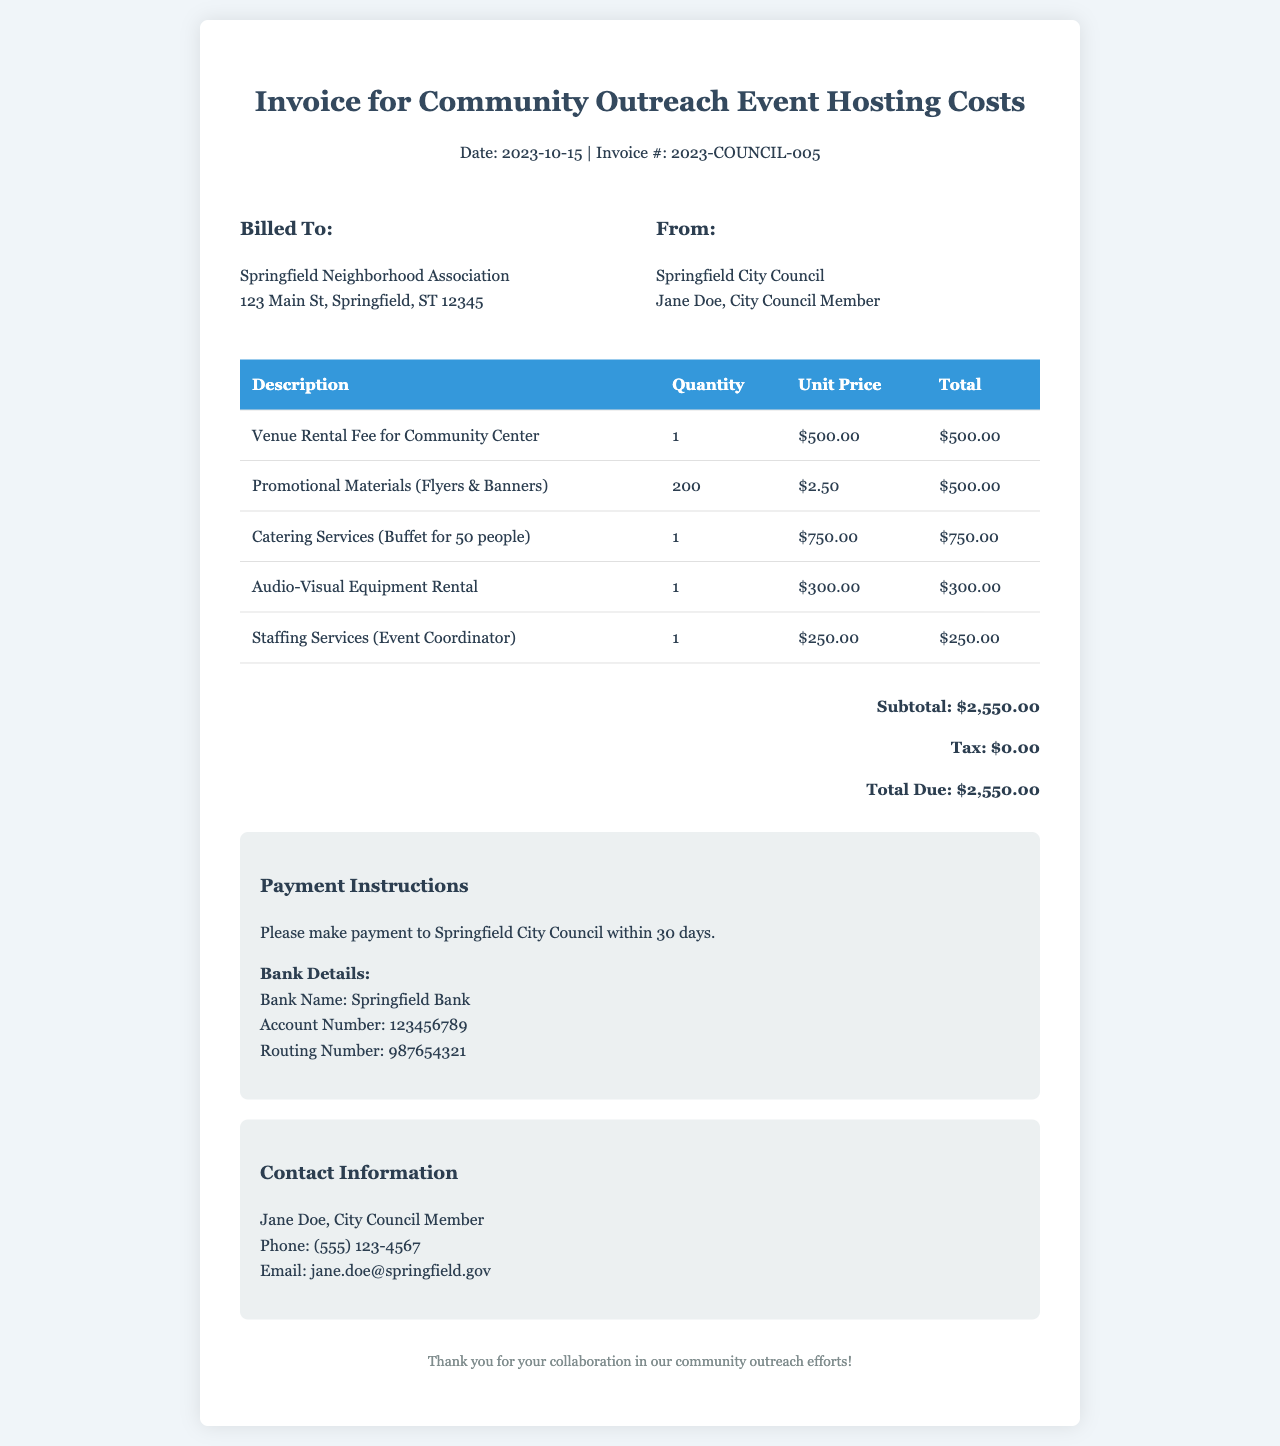What is the date of the invoice? The date is specified in the header of the invoice.
Answer: 2023-10-15 Who is billed for the services? The "Billed To" section lists the recipient of the invoice.
Answer: Springfield Neighborhood Association What is the total amount due? The total amount is outlined in the summary section at the bottom of the invoice.
Answer: $2,550.00 How much did the venue rental cost? The cost of the venue rental is detailed in the itemized list of expenses.
Answer: $500.00 What is the unit price for promotional materials? The unit price can be found in the table, specifically for the row detailing promotional materials.
Answer: $2.50 What type of catering service was provided? The description section in the table indicates the nature of the catering service provided.
Answer: Buffet for 50 people How many flyers and banners were ordered? This information is noted in the quantity under the promotional materials section.
Answer: 200 What services were included under staffing? The itemized list provides a description of the staffing service offered.
Answer: Event Coordinator What bank is specified for payment? The payment instructions portion of the document mentions specific bank details.
Answer: Springfield Bank 